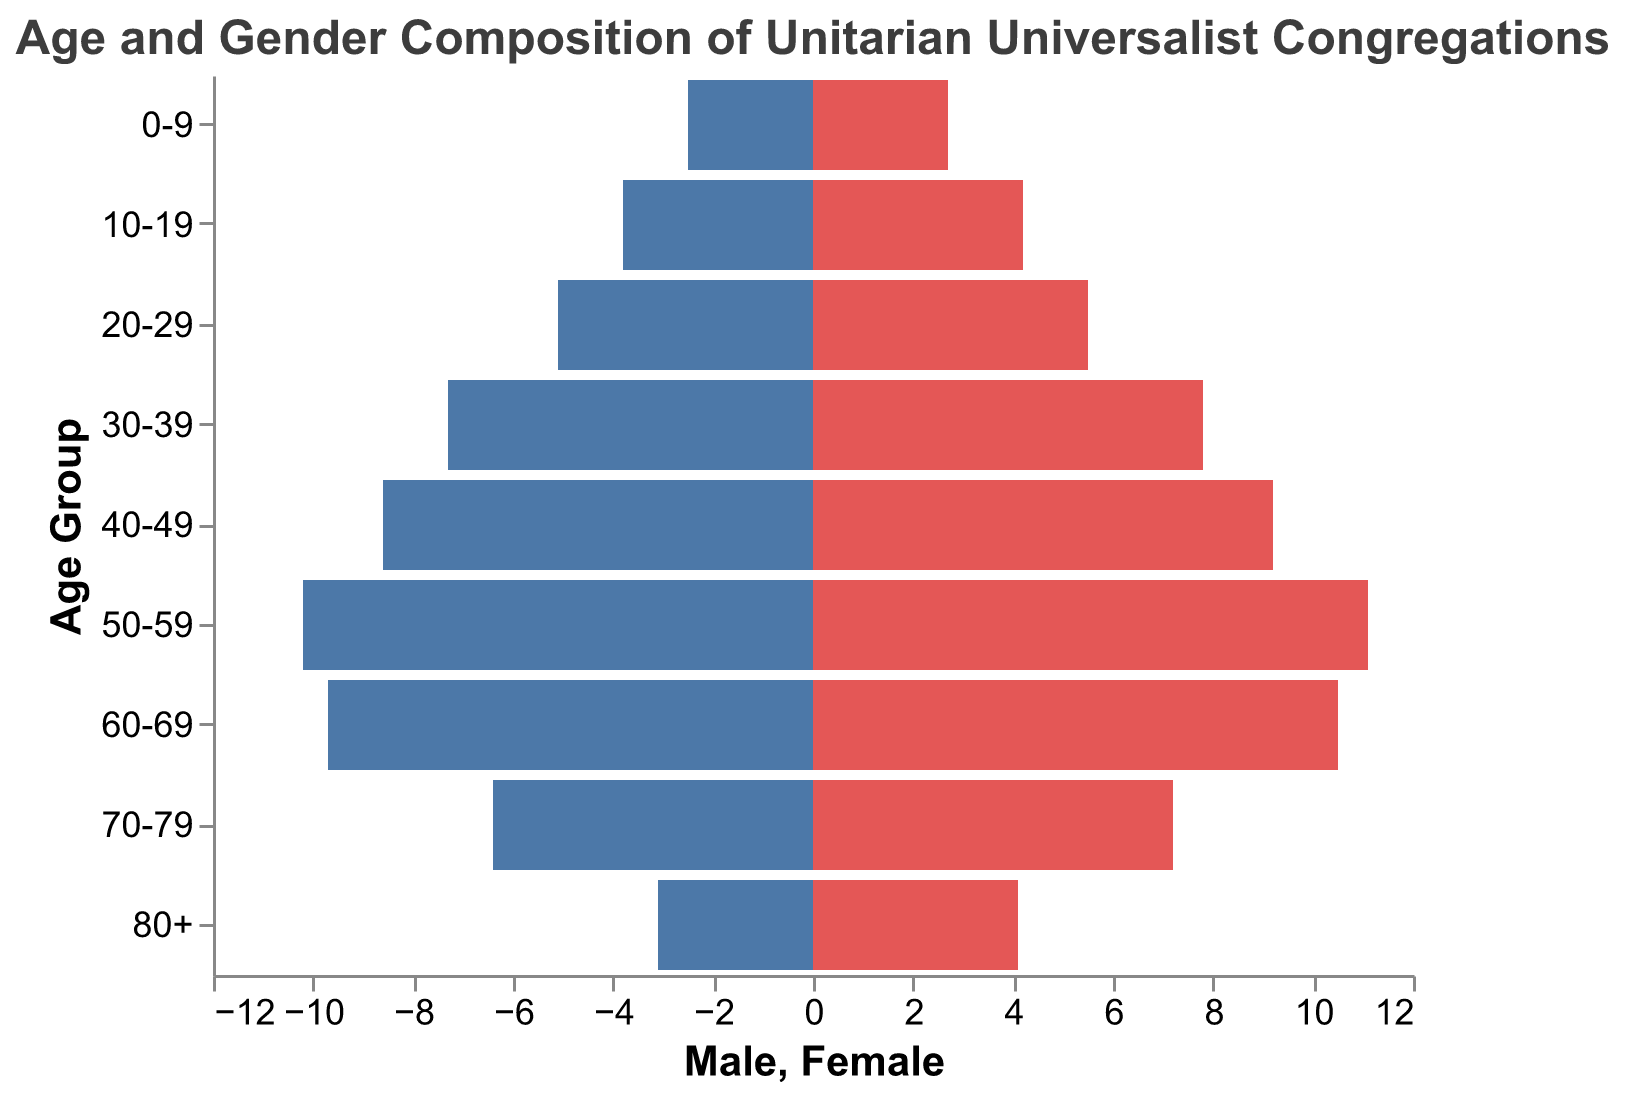What's the title of the figure? The title of the figure is typically located at the top and is meant to describe what the chart is about.
Answer: Age and Gender Composition of Unitarian Universalist Congregations What is the age group with the highest number of females? You need to look at the bars for females (colored in red) and identify which age group has the longest bar.
Answer: 50-59 Which gender has more individuals in the age group 30-39? Compare the lengths of the bars for both genders within the 30-39 age group to see which one is longer.
Answer: Female How many males are there in the 60-69 age group? Look at the length of the bar for males (colored in blue and plotted negatively) in the 60-69 age group. The data indicates 9.7%.
Answer: 9.7% In which age group is the gender disparity the largest in favor of females? You need to check the difference between the lengths of the male and female bars for each age group and identify the largest difference. The 50-59 age group has the largest disparity with females at 11.1% and males at 10.2%.
Answer: 50-59 What is the combined percentage of males and females in the 80+ age group? Add the percentages of both males and females in the 80+ age group. Males are 3.1% and females are 4.1%, so 3.1 + 4.1 = 7.2%.
Answer: 7.2% Which age group has the smallest number of individuals combined? Add the percentages for males and females across all age groups and identify the age group with the smallest total value. The 0-9 age group with 2.5% males and 2.7% females gives 2.5 + 2.7 = 5.2%.
Answer: 0-9 Compare the male percentages between the age groups 20-29 and 70-79. Which group has the higher percentage? Look at the bars for males in both age groups. The data shows 20-29 has 5.1% and 70-79 has 6.4%.
Answer: 70-79 What is the average percentage of females across all age groups? Add up the percentages of females for each age group and divide by the number of age groups (9). (2.7 + 4.2 + 5.5 + 7.8 + 9.2 + 11.1 + 10.5 + 7.2 + 4.1) / 9 = 6.91%.
Answer: 6.91% What is the difference in the total number of individuals between the age groups 50-59 and 10-19? Calculate the combined percentages for both genders in each age group, then find the difference. For 50-59: 10.2% males + 11.1% females = 21.3%. For 10-19: 3.8% males + 4.2% females = 8.0%. The difference is 21.3 - 8.0 = 13.3%.
Answer: 13.3% 